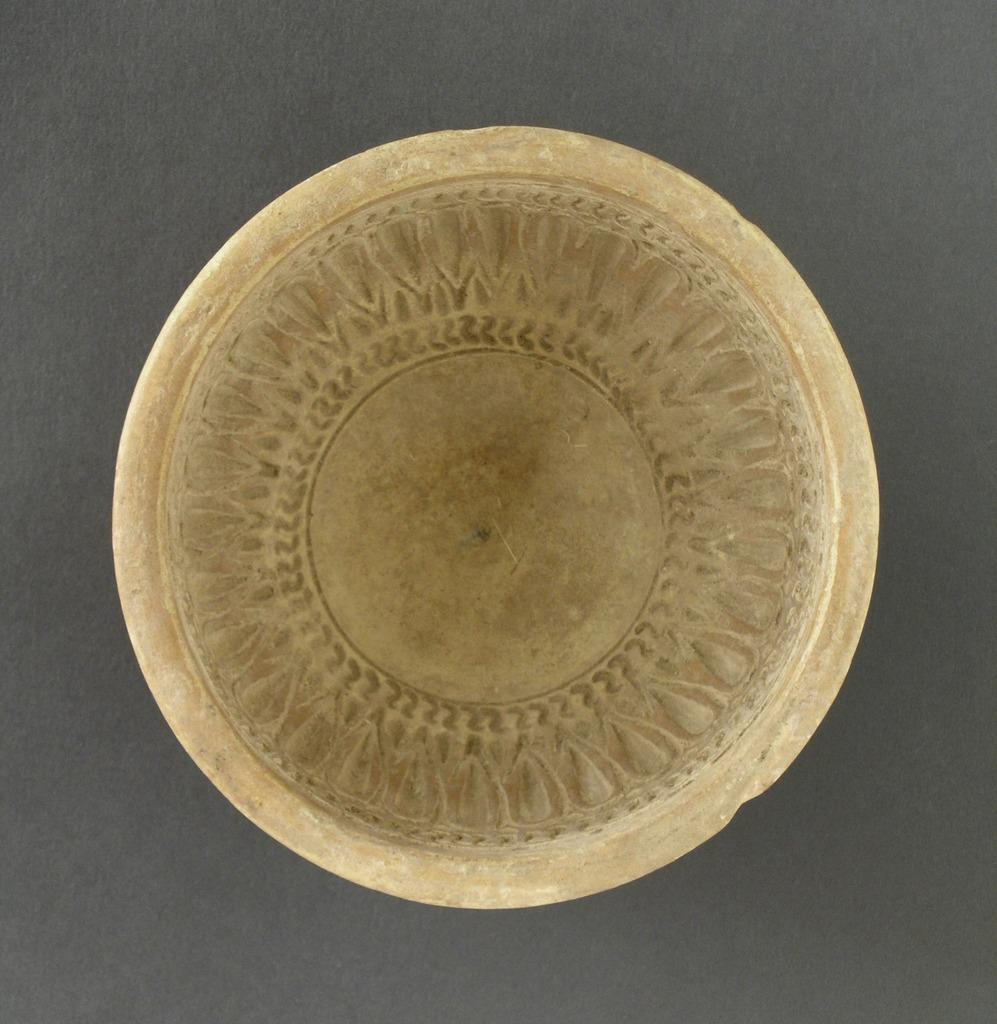What object is present on the grey surface in the image? There is a plate in the image. What color is the plate? The plate is cream-colored. Where is the plate located in the image? The plate is placed on a grey surface. What can be seen on the plate? There is a design on the plate. What type of stick is used to apply polish to the plate in the image? There is no stick or polish present in the image; it only features a plate with a design on it. 